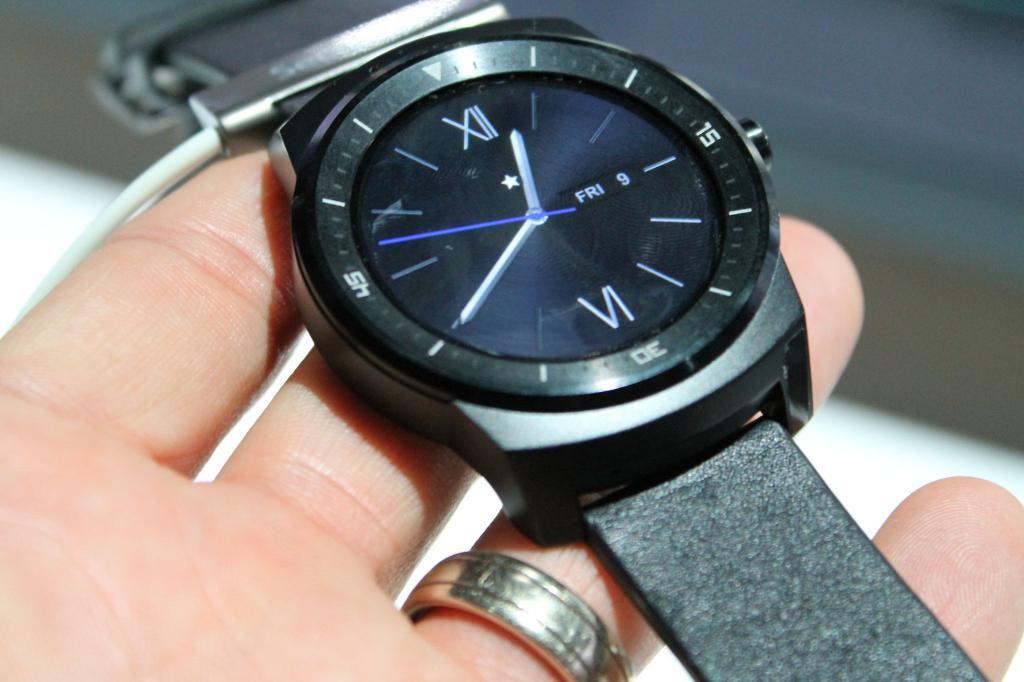What roman number is on the bottom?
Offer a very short reply. Vi. 